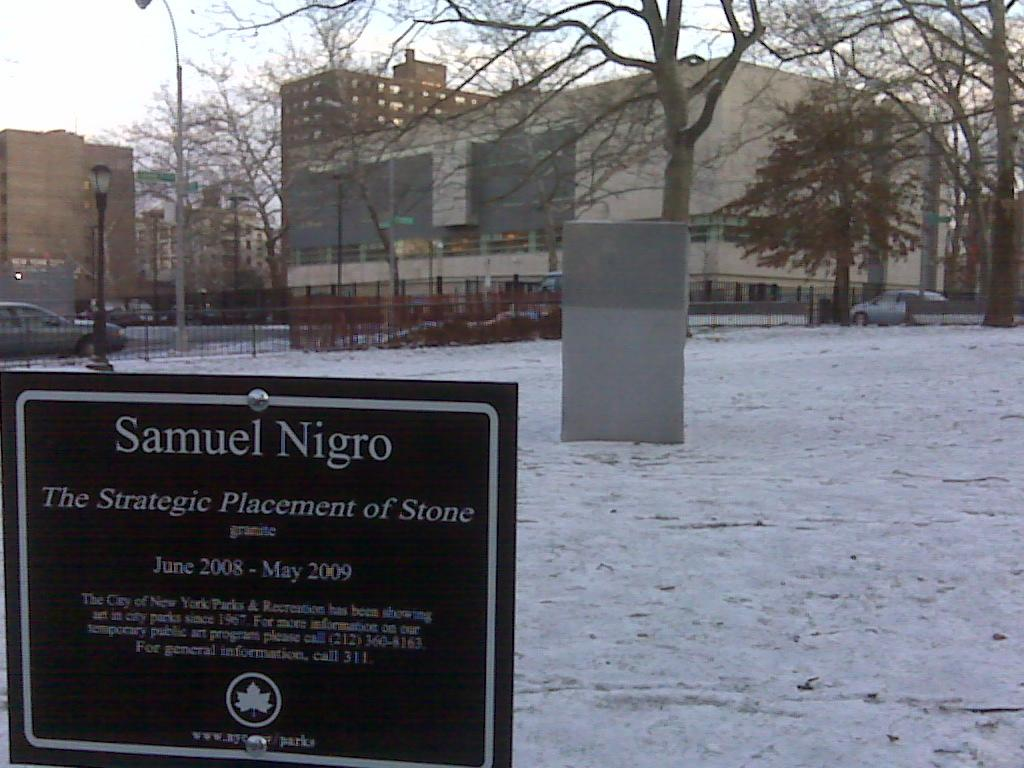What is written or displayed on the board in the image? There is a board with text in the image, but the specific content of the text is not mentioned in the facts. What is the weather like in the image? The weather is snowy in the image. What type of barrier can be seen in the image? There is a fence in the image. What types of vehicles are present in the image? There are vehicles in the image, but the specific types of vehicles are not mentioned in the facts. What type of vegetation is present in the image? There are trees in the image. What type of structures are present in the image? There are buildings in the image. What is the tall, thin object in the image? There is a pole in the image. What can be seen in the background of the image? The sky is visible in the background of the image. Where is the park located in the image? There is no park mentioned or visible in the image. What color is the stocking hanging on the pole in the image? There is no stocking present in the image. What thought is being expressed by the person in the image? There is no person present in the image, so it is impossible to determine their thoughts. 